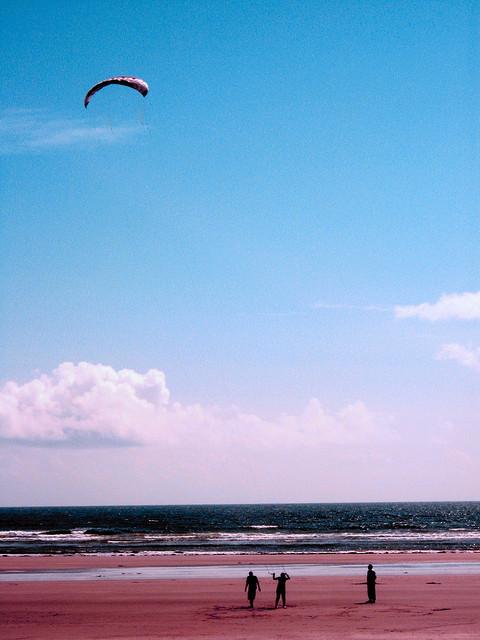What is up in the air?
Quick response, please. Kite. How many people are there?
Answer briefly. 3. How high in the air is it?
Write a very short answer. Very high. What is the man standing in?
Concise answer only. Sand. 